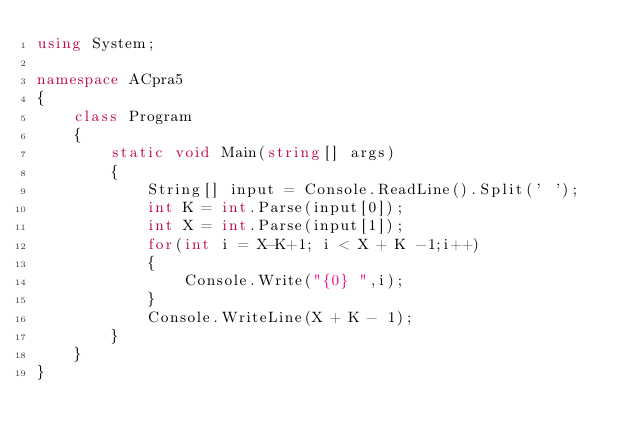<code> <loc_0><loc_0><loc_500><loc_500><_C#_>using System;

namespace ACpra5
{
    class Program
    {
        static void Main(string[] args)
        {
            String[] input = Console.ReadLine().Split(' ');
            int K = int.Parse(input[0]);
            int X = int.Parse(input[1]);
            for(int i = X-K+1; i < X + K -1;i++)
            {
                Console.Write("{0} ",i);
            }
            Console.WriteLine(X + K - 1);
        }
    }
}

</code> 